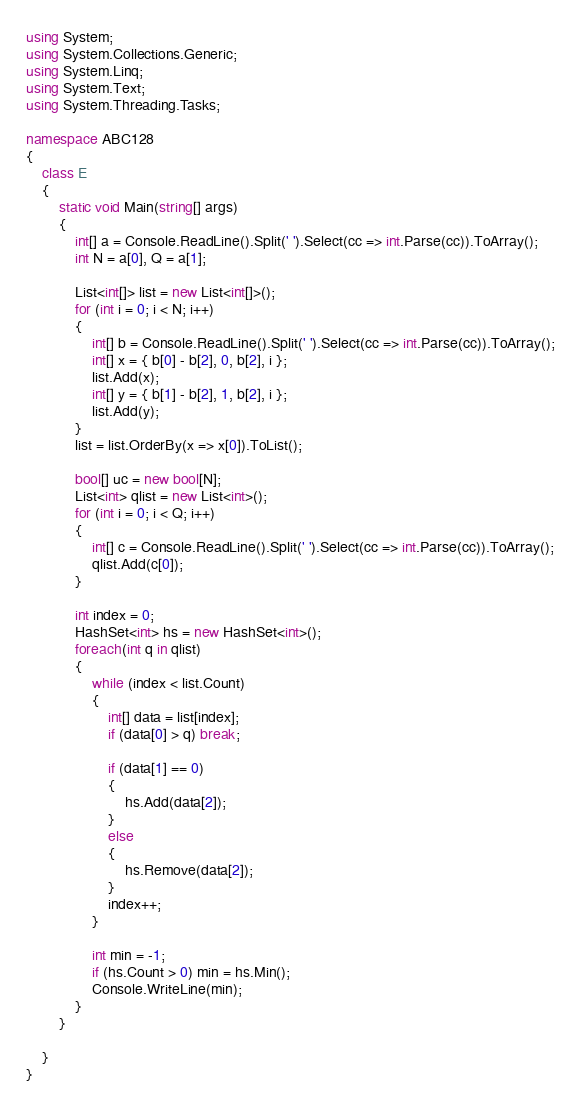Convert code to text. <code><loc_0><loc_0><loc_500><loc_500><_C#_>using System;
using System.Collections.Generic;
using System.Linq;
using System.Text;
using System.Threading.Tasks;

namespace ABC128
{
    class E
    {
        static void Main(string[] args)
        {
            int[] a = Console.ReadLine().Split(' ').Select(cc => int.Parse(cc)).ToArray();
            int N = a[0], Q = a[1];

            List<int[]> list = new List<int[]>();
            for (int i = 0; i < N; i++)
            {
                int[] b = Console.ReadLine().Split(' ').Select(cc => int.Parse(cc)).ToArray();
                int[] x = { b[0] - b[2], 0, b[2], i };
                list.Add(x);
                int[] y = { b[1] - b[2], 1, b[2], i };
                list.Add(y);
            }
            list = list.OrderBy(x => x[0]).ToList();

            bool[] uc = new bool[N];
            List<int> qlist = new List<int>();
            for (int i = 0; i < Q; i++)
            {
                int[] c = Console.ReadLine().Split(' ').Select(cc => int.Parse(cc)).ToArray();
                qlist.Add(c[0]);
            }

            int index = 0;
            HashSet<int> hs = new HashSet<int>();
            foreach(int q in qlist)
            {
                while (index < list.Count)
                {
                    int[] data = list[index];
                    if (data[0] > q) break;

                    if (data[1] == 0)
                    {
                        hs.Add(data[2]);
                    }
                    else
                    {
                        hs.Remove(data[2]);
                    }
                    index++;
                }

                int min = -1;
                if (hs.Count > 0) min = hs.Min();
                Console.WriteLine(min);
            }
        }

    }
}
</code> 